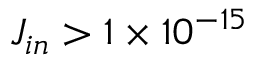<formula> <loc_0><loc_0><loc_500><loc_500>J _ { i n } > 1 \times 1 0 ^ { - 1 5 }</formula> 